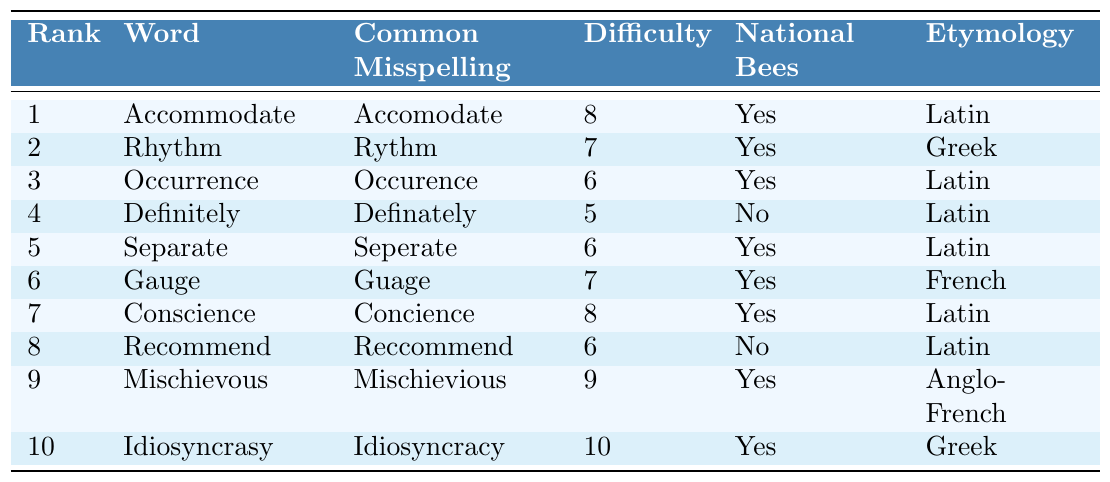What is the most commonly misspelled word in English? The table indicates that the word ranked 1 is "Accommodate," which is the most commonly misspelled word.
Answer: Accommodate How many words in the table have a difficulty level of 6? By inspecting the table, I can see there are three words with a difficulty level of 6: "Occurrence," "Separate," and "Recommend."
Answer: 3 What is the common misspelling of the word "Gauge"? The table shows that the common misspelling of "Gauge" is "Guage."
Answer: Guage Does the word "Definitely" appear in National Bees? The table states that "Definitely" does not appear in National Bees; it indicates "No."
Answer: No Which word has the highest difficulty level and what is it? Scanning the table, I find that "Idiosyncrasy" has the highest difficulty level of 10.
Answer: Idiosyncrasy What is the average difficulty level of the words that appear in National Bees? The difficulty levels for words that appear in National Bees are 8, 7, 6, 6, 7, 8, 9, and 10. Adding these gives 61 and there are 8 words, so the average is 61/8 = 7.625.
Answer: 7.625 Which two words have a common misspelling that starts with "C" and what are their correct spellings? The table shows that both "Conscience" (misspelled as "Concience") and "Occurrence" (misspelled as "Occurence") have common misspellings starting with "C."
Answer: Conscience, Occurrence How many words with Latin etymology appear in National Bees? Looking at the table, I find that the words with Latin etymology that appear in National Bees are "Accommodate," "Occurrence," "Separate," "Conscience," and "Recommend." This totals to five.
Answer: 5 Which word has a difficulty level lower than 7 and does not appear in National Bees? In examining the table, "Definitely" has a difficulty level of 5 and does not appear in National Bees.
Answer: Definitely Is "Mischievous" the only word that has a difficulty level of 9? Reviewing the table shows "Mischievous" is indeed the only word listed with a difficulty level of 9.
Answer: Yes 